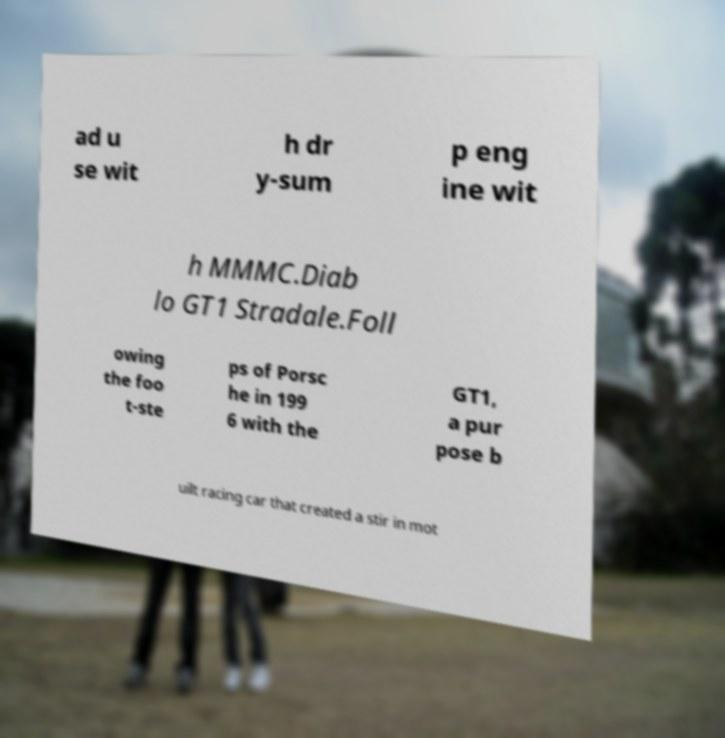Could you assist in decoding the text presented in this image and type it out clearly? ad u se wit h dr y-sum p eng ine wit h MMMC.Diab lo GT1 Stradale.Foll owing the foo t-ste ps of Porsc he in 199 6 with the GT1, a pur pose b uilt racing car that created a stir in mot 